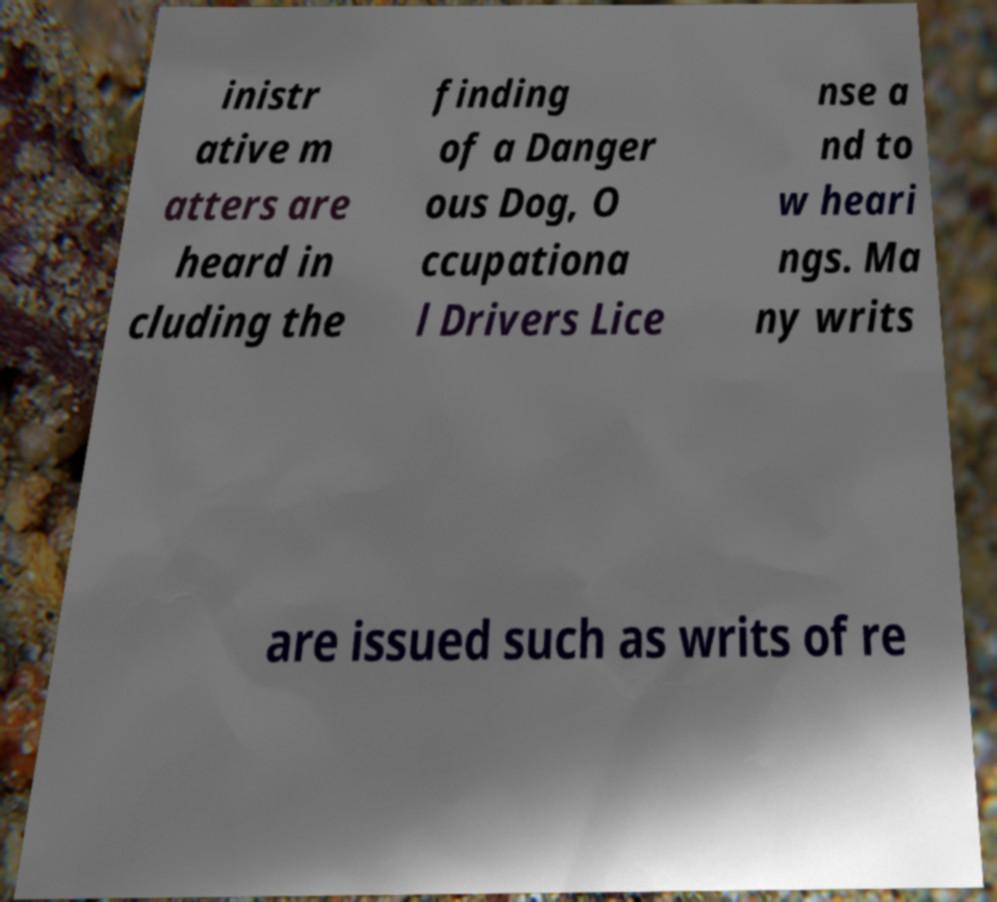Can you accurately transcribe the text from the provided image for me? inistr ative m atters are heard in cluding the finding of a Danger ous Dog, O ccupationa l Drivers Lice nse a nd to w heari ngs. Ma ny writs are issued such as writs of re 